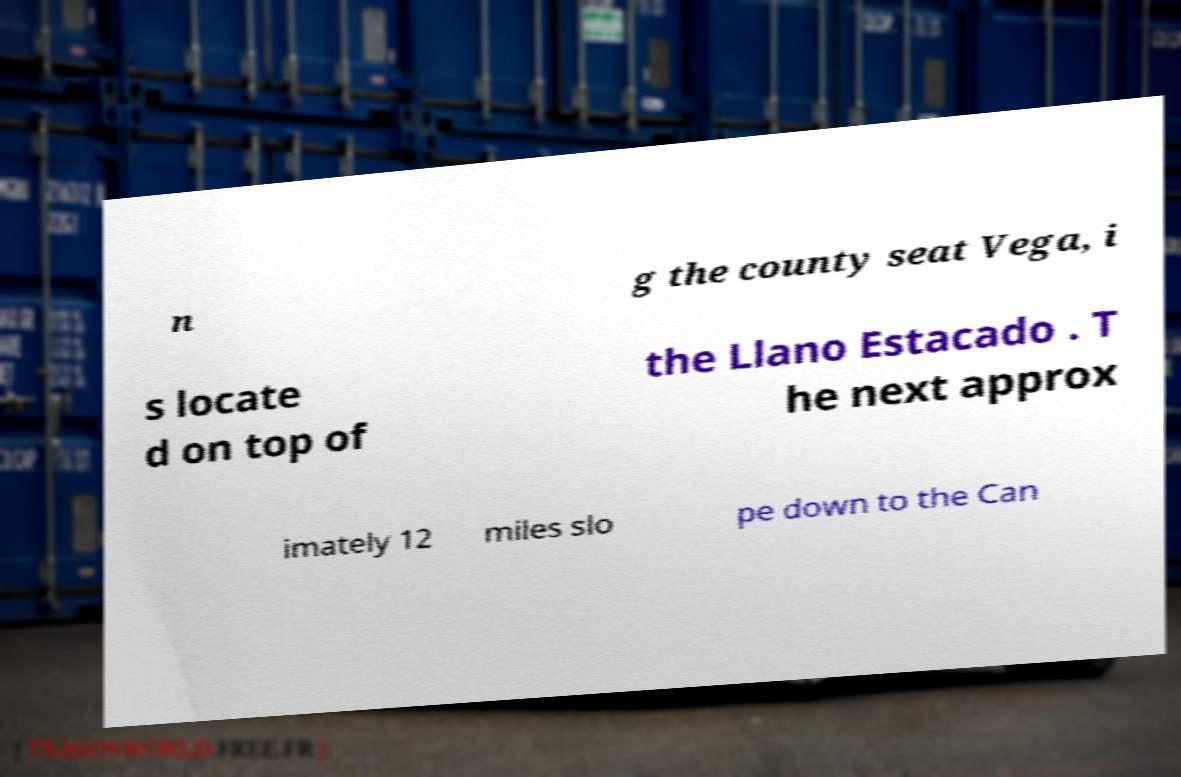Could you extract and type out the text from this image? n g the county seat Vega, i s locate d on top of the Llano Estacado . T he next approx imately 12 miles slo pe down to the Can 